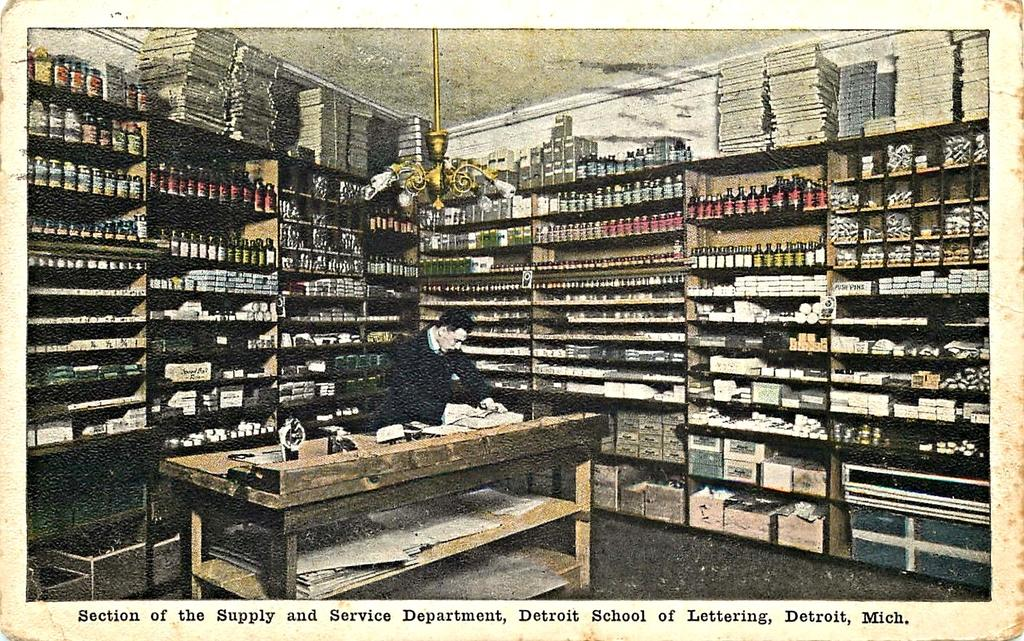<image>
Summarize the visual content of the image. A man is in a shop called the Section of the Supply and Service Department. 